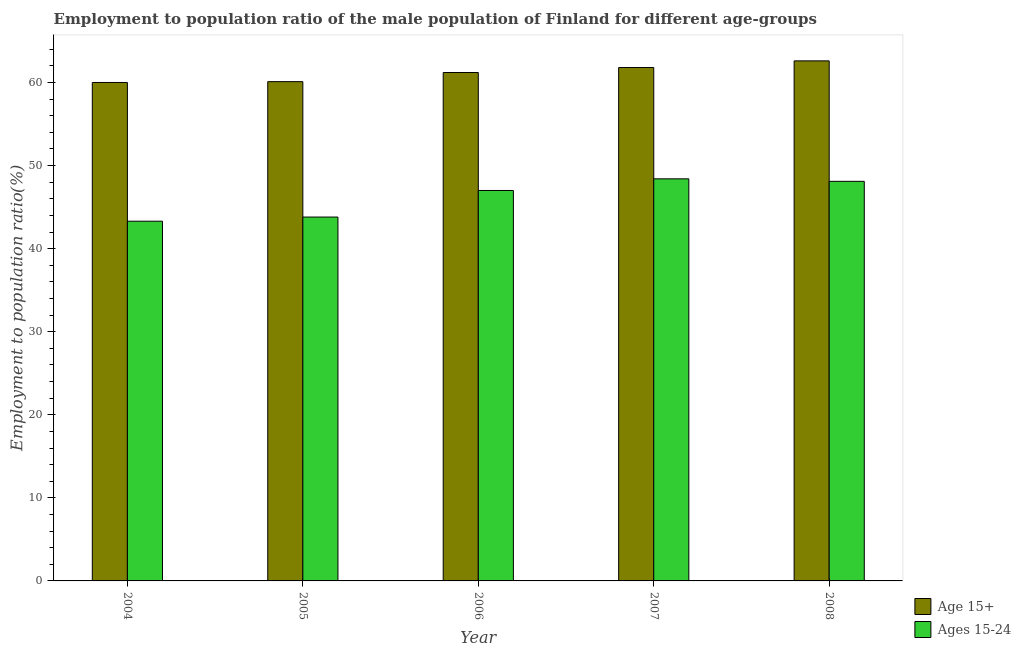How many different coloured bars are there?
Provide a succinct answer. 2. How many groups of bars are there?
Provide a succinct answer. 5. Are the number of bars per tick equal to the number of legend labels?
Ensure brevity in your answer.  Yes. How many bars are there on the 5th tick from the right?
Keep it short and to the point. 2. What is the label of the 5th group of bars from the left?
Your answer should be very brief. 2008. In how many cases, is the number of bars for a given year not equal to the number of legend labels?
Your response must be concise. 0. What is the employment to population ratio(age 15-24) in 2004?
Your answer should be very brief. 43.3. Across all years, what is the maximum employment to population ratio(age 15+)?
Your answer should be compact. 62.6. Across all years, what is the minimum employment to population ratio(age 15+)?
Keep it short and to the point. 60. In which year was the employment to population ratio(age 15-24) minimum?
Make the answer very short. 2004. What is the total employment to population ratio(age 15-24) in the graph?
Provide a succinct answer. 230.6. What is the difference between the employment to population ratio(age 15-24) in 2005 and that in 2006?
Offer a terse response. -3.2. What is the difference between the employment to population ratio(age 15+) in 2005 and the employment to population ratio(age 15-24) in 2004?
Offer a terse response. 0.1. What is the average employment to population ratio(age 15-24) per year?
Your response must be concise. 46.12. In the year 2006, what is the difference between the employment to population ratio(age 15-24) and employment to population ratio(age 15+)?
Offer a terse response. 0. In how many years, is the employment to population ratio(age 15+) greater than 32 %?
Offer a terse response. 5. What is the ratio of the employment to population ratio(age 15-24) in 2005 to that in 2007?
Provide a succinct answer. 0.9. Is the employment to population ratio(age 15-24) in 2007 less than that in 2008?
Give a very brief answer. No. Is the difference between the employment to population ratio(age 15+) in 2004 and 2008 greater than the difference between the employment to population ratio(age 15-24) in 2004 and 2008?
Provide a short and direct response. No. What is the difference between the highest and the second highest employment to population ratio(age 15-24)?
Provide a succinct answer. 0.3. What is the difference between the highest and the lowest employment to population ratio(age 15-24)?
Provide a succinct answer. 5.1. Is the sum of the employment to population ratio(age 15-24) in 2004 and 2008 greater than the maximum employment to population ratio(age 15+) across all years?
Provide a short and direct response. Yes. What does the 2nd bar from the left in 2005 represents?
Your answer should be compact. Ages 15-24. What does the 2nd bar from the right in 2007 represents?
Provide a succinct answer. Age 15+. How many bars are there?
Provide a succinct answer. 10. Are all the bars in the graph horizontal?
Give a very brief answer. No. How many years are there in the graph?
Offer a terse response. 5. How many legend labels are there?
Provide a succinct answer. 2. What is the title of the graph?
Provide a succinct answer. Employment to population ratio of the male population of Finland for different age-groups. What is the Employment to population ratio(%) in Age 15+ in 2004?
Keep it short and to the point. 60. What is the Employment to population ratio(%) of Ages 15-24 in 2004?
Provide a short and direct response. 43.3. What is the Employment to population ratio(%) in Age 15+ in 2005?
Offer a terse response. 60.1. What is the Employment to population ratio(%) in Ages 15-24 in 2005?
Offer a terse response. 43.8. What is the Employment to population ratio(%) in Age 15+ in 2006?
Ensure brevity in your answer.  61.2. What is the Employment to population ratio(%) in Ages 15-24 in 2006?
Your answer should be compact. 47. What is the Employment to population ratio(%) of Age 15+ in 2007?
Offer a terse response. 61.8. What is the Employment to population ratio(%) of Ages 15-24 in 2007?
Your answer should be compact. 48.4. What is the Employment to population ratio(%) in Age 15+ in 2008?
Offer a terse response. 62.6. What is the Employment to population ratio(%) in Ages 15-24 in 2008?
Your response must be concise. 48.1. Across all years, what is the maximum Employment to population ratio(%) of Age 15+?
Ensure brevity in your answer.  62.6. Across all years, what is the maximum Employment to population ratio(%) in Ages 15-24?
Your answer should be compact. 48.4. Across all years, what is the minimum Employment to population ratio(%) in Ages 15-24?
Your response must be concise. 43.3. What is the total Employment to population ratio(%) in Age 15+ in the graph?
Offer a very short reply. 305.7. What is the total Employment to population ratio(%) in Ages 15-24 in the graph?
Your response must be concise. 230.6. What is the difference between the Employment to population ratio(%) of Age 15+ in 2004 and that in 2006?
Make the answer very short. -1.2. What is the difference between the Employment to population ratio(%) of Ages 15-24 in 2004 and that in 2006?
Your answer should be very brief. -3.7. What is the difference between the Employment to population ratio(%) of Ages 15-24 in 2004 and that in 2007?
Provide a short and direct response. -5.1. What is the difference between the Employment to population ratio(%) in Ages 15-24 in 2004 and that in 2008?
Make the answer very short. -4.8. What is the difference between the Employment to population ratio(%) in Age 15+ in 2005 and that in 2007?
Your answer should be compact. -1.7. What is the difference between the Employment to population ratio(%) of Ages 15-24 in 2005 and that in 2008?
Your answer should be compact. -4.3. What is the difference between the Employment to population ratio(%) in Age 15+ in 2006 and that in 2007?
Your response must be concise. -0.6. What is the difference between the Employment to population ratio(%) of Age 15+ in 2004 and the Employment to population ratio(%) of Ages 15-24 in 2005?
Offer a terse response. 16.2. What is the difference between the Employment to population ratio(%) in Age 15+ in 2004 and the Employment to population ratio(%) in Ages 15-24 in 2006?
Provide a succinct answer. 13. What is the difference between the Employment to population ratio(%) in Age 15+ in 2004 and the Employment to population ratio(%) in Ages 15-24 in 2007?
Make the answer very short. 11.6. What is the difference between the Employment to population ratio(%) of Age 15+ in 2005 and the Employment to population ratio(%) of Ages 15-24 in 2007?
Your response must be concise. 11.7. What is the difference between the Employment to population ratio(%) in Age 15+ in 2005 and the Employment to population ratio(%) in Ages 15-24 in 2008?
Give a very brief answer. 12. What is the difference between the Employment to population ratio(%) in Age 15+ in 2006 and the Employment to population ratio(%) in Ages 15-24 in 2007?
Offer a very short reply. 12.8. What is the difference between the Employment to population ratio(%) in Age 15+ in 2006 and the Employment to population ratio(%) in Ages 15-24 in 2008?
Your answer should be compact. 13.1. What is the average Employment to population ratio(%) of Age 15+ per year?
Offer a very short reply. 61.14. What is the average Employment to population ratio(%) in Ages 15-24 per year?
Make the answer very short. 46.12. In the year 2004, what is the difference between the Employment to population ratio(%) of Age 15+ and Employment to population ratio(%) of Ages 15-24?
Your answer should be very brief. 16.7. In the year 2005, what is the difference between the Employment to population ratio(%) in Age 15+ and Employment to population ratio(%) in Ages 15-24?
Offer a terse response. 16.3. In the year 2007, what is the difference between the Employment to population ratio(%) in Age 15+ and Employment to population ratio(%) in Ages 15-24?
Offer a very short reply. 13.4. In the year 2008, what is the difference between the Employment to population ratio(%) in Age 15+ and Employment to population ratio(%) in Ages 15-24?
Your answer should be compact. 14.5. What is the ratio of the Employment to population ratio(%) of Age 15+ in 2004 to that in 2005?
Offer a terse response. 1. What is the ratio of the Employment to population ratio(%) in Ages 15-24 in 2004 to that in 2005?
Make the answer very short. 0.99. What is the ratio of the Employment to population ratio(%) in Age 15+ in 2004 to that in 2006?
Keep it short and to the point. 0.98. What is the ratio of the Employment to population ratio(%) in Ages 15-24 in 2004 to that in 2006?
Keep it short and to the point. 0.92. What is the ratio of the Employment to population ratio(%) in Age 15+ in 2004 to that in 2007?
Offer a terse response. 0.97. What is the ratio of the Employment to population ratio(%) in Ages 15-24 in 2004 to that in 2007?
Provide a succinct answer. 0.89. What is the ratio of the Employment to population ratio(%) of Age 15+ in 2004 to that in 2008?
Provide a succinct answer. 0.96. What is the ratio of the Employment to population ratio(%) of Ages 15-24 in 2004 to that in 2008?
Make the answer very short. 0.9. What is the ratio of the Employment to population ratio(%) in Ages 15-24 in 2005 to that in 2006?
Your response must be concise. 0.93. What is the ratio of the Employment to population ratio(%) of Age 15+ in 2005 to that in 2007?
Your answer should be compact. 0.97. What is the ratio of the Employment to population ratio(%) of Ages 15-24 in 2005 to that in 2007?
Your answer should be very brief. 0.91. What is the ratio of the Employment to population ratio(%) in Age 15+ in 2005 to that in 2008?
Your answer should be compact. 0.96. What is the ratio of the Employment to population ratio(%) in Ages 15-24 in 2005 to that in 2008?
Provide a short and direct response. 0.91. What is the ratio of the Employment to population ratio(%) of Age 15+ in 2006 to that in 2007?
Ensure brevity in your answer.  0.99. What is the ratio of the Employment to population ratio(%) in Ages 15-24 in 2006 to that in 2007?
Your answer should be compact. 0.97. What is the ratio of the Employment to population ratio(%) of Age 15+ in 2006 to that in 2008?
Offer a very short reply. 0.98. What is the ratio of the Employment to population ratio(%) in Ages 15-24 in 2006 to that in 2008?
Give a very brief answer. 0.98. What is the ratio of the Employment to population ratio(%) in Age 15+ in 2007 to that in 2008?
Your answer should be compact. 0.99. What is the ratio of the Employment to population ratio(%) of Ages 15-24 in 2007 to that in 2008?
Your answer should be very brief. 1.01. What is the difference between the highest and the second highest Employment to population ratio(%) of Age 15+?
Your answer should be compact. 0.8. 